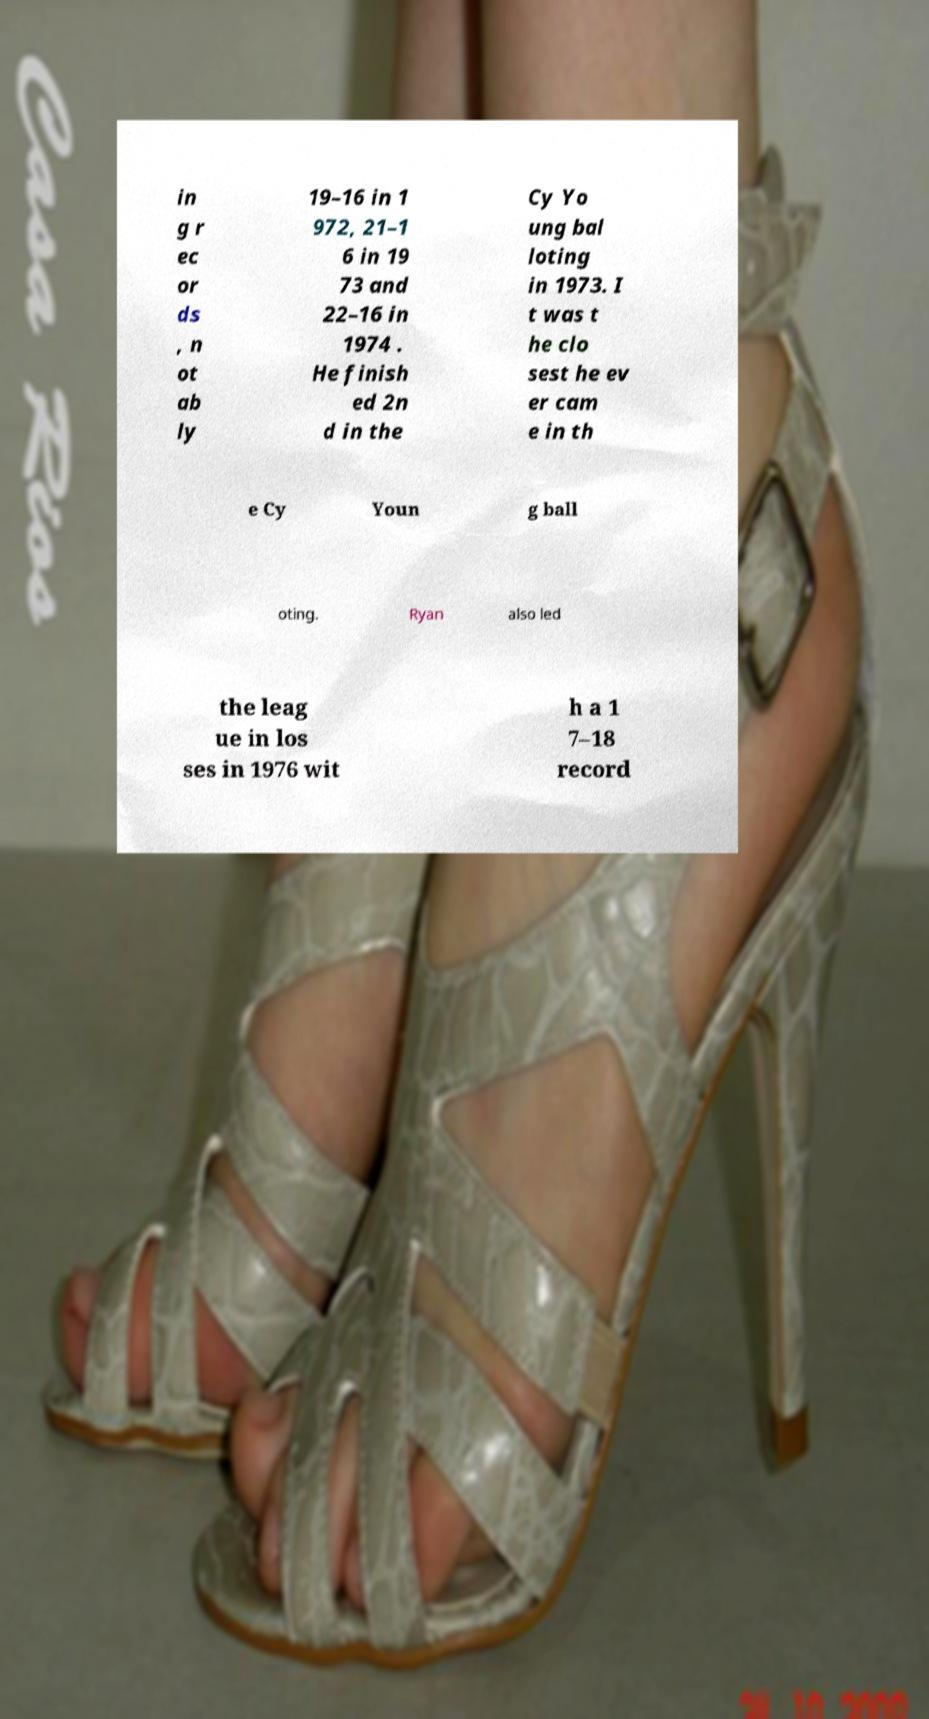I need the written content from this picture converted into text. Can you do that? in g r ec or ds , n ot ab ly 19–16 in 1 972, 21–1 6 in 19 73 and 22–16 in 1974 . He finish ed 2n d in the Cy Yo ung bal loting in 1973. I t was t he clo sest he ev er cam e in th e Cy Youn g ball oting. Ryan also led the leag ue in los ses in 1976 wit h a 1 7–18 record 